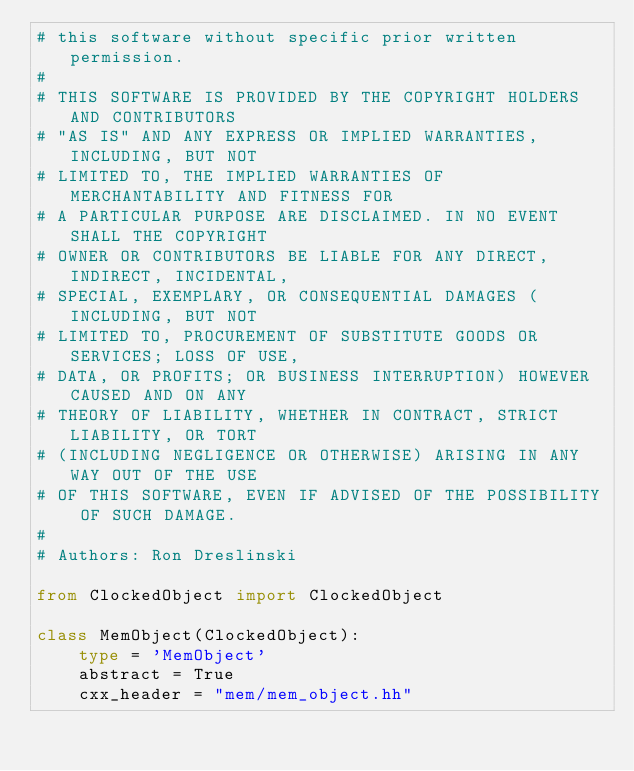Convert code to text. <code><loc_0><loc_0><loc_500><loc_500><_Python_># this software without specific prior written permission.
#
# THIS SOFTWARE IS PROVIDED BY THE COPYRIGHT HOLDERS AND CONTRIBUTORS
# "AS IS" AND ANY EXPRESS OR IMPLIED WARRANTIES, INCLUDING, BUT NOT
# LIMITED TO, THE IMPLIED WARRANTIES OF MERCHANTABILITY AND FITNESS FOR
# A PARTICULAR PURPOSE ARE DISCLAIMED. IN NO EVENT SHALL THE COPYRIGHT
# OWNER OR CONTRIBUTORS BE LIABLE FOR ANY DIRECT, INDIRECT, INCIDENTAL,
# SPECIAL, EXEMPLARY, OR CONSEQUENTIAL DAMAGES (INCLUDING, BUT NOT
# LIMITED TO, PROCUREMENT OF SUBSTITUTE GOODS OR SERVICES; LOSS OF USE,
# DATA, OR PROFITS; OR BUSINESS INTERRUPTION) HOWEVER CAUSED AND ON ANY
# THEORY OF LIABILITY, WHETHER IN CONTRACT, STRICT LIABILITY, OR TORT
# (INCLUDING NEGLIGENCE OR OTHERWISE) ARISING IN ANY WAY OUT OF THE USE
# OF THIS SOFTWARE, EVEN IF ADVISED OF THE POSSIBILITY OF SUCH DAMAGE.
#
# Authors: Ron Dreslinski

from ClockedObject import ClockedObject

class MemObject(ClockedObject):
    type = 'MemObject'
    abstract = True
    cxx_header = "mem/mem_object.hh"
</code> 